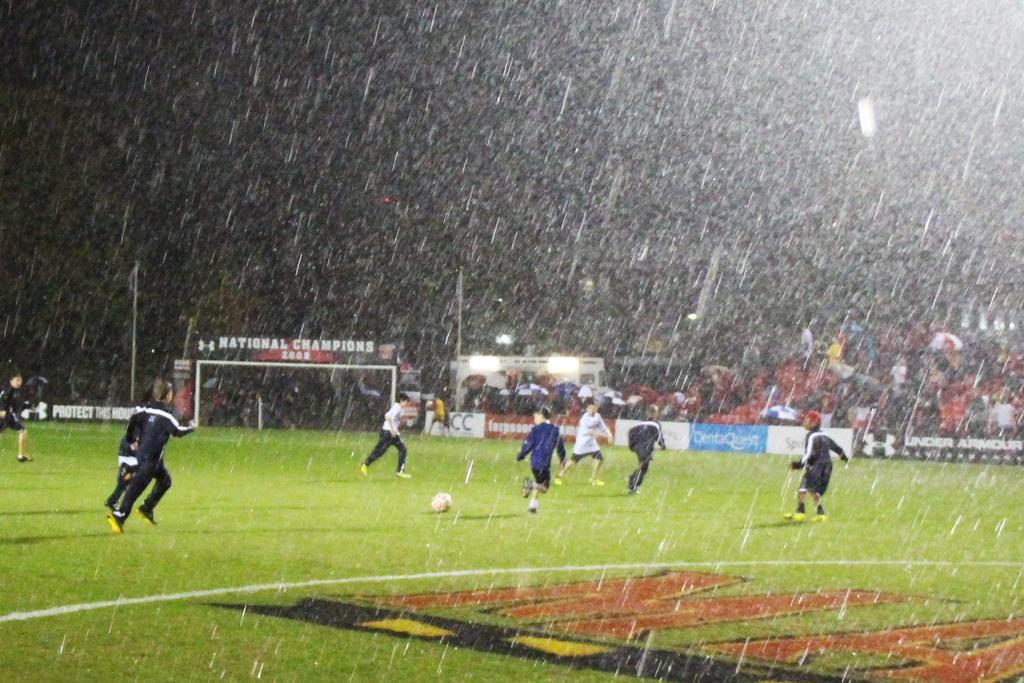What type of champions are they?
Ensure brevity in your answer.  National. Who is the advertiser on the blue sign?
Provide a succinct answer. Dentaquest. 